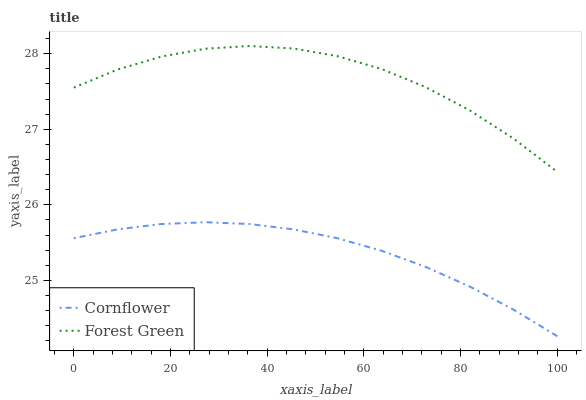Does Cornflower have the minimum area under the curve?
Answer yes or no. Yes. Does Forest Green have the maximum area under the curve?
Answer yes or no. Yes. Does Forest Green have the minimum area under the curve?
Answer yes or no. No. Is Cornflower the smoothest?
Answer yes or no. Yes. Is Forest Green the roughest?
Answer yes or no. Yes. Is Forest Green the smoothest?
Answer yes or no. No. Does Cornflower have the lowest value?
Answer yes or no. Yes. Does Forest Green have the lowest value?
Answer yes or no. No. Does Forest Green have the highest value?
Answer yes or no. Yes. Is Cornflower less than Forest Green?
Answer yes or no. Yes. Is Forest Green greater than Cornflower?
Answer yes or no. Yes. Does Cornflower intersect Forest Green?
Answer yes or no. No. 